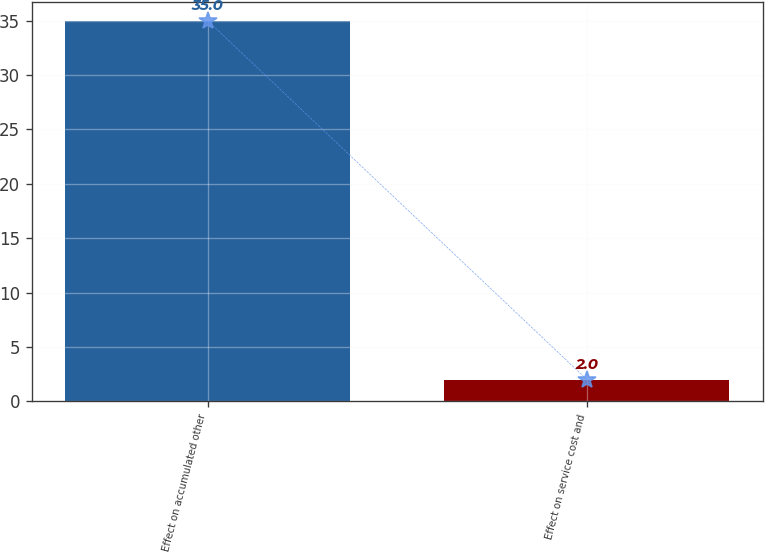Convert chart to OTSL. <chart><loc_0><loc_0><loc_500><loc_500><bar_chart><fcel>Effect on accumulated other<fcel>Effect on service cost and<nl><fcel>35<fcel>2<nl></chart> 